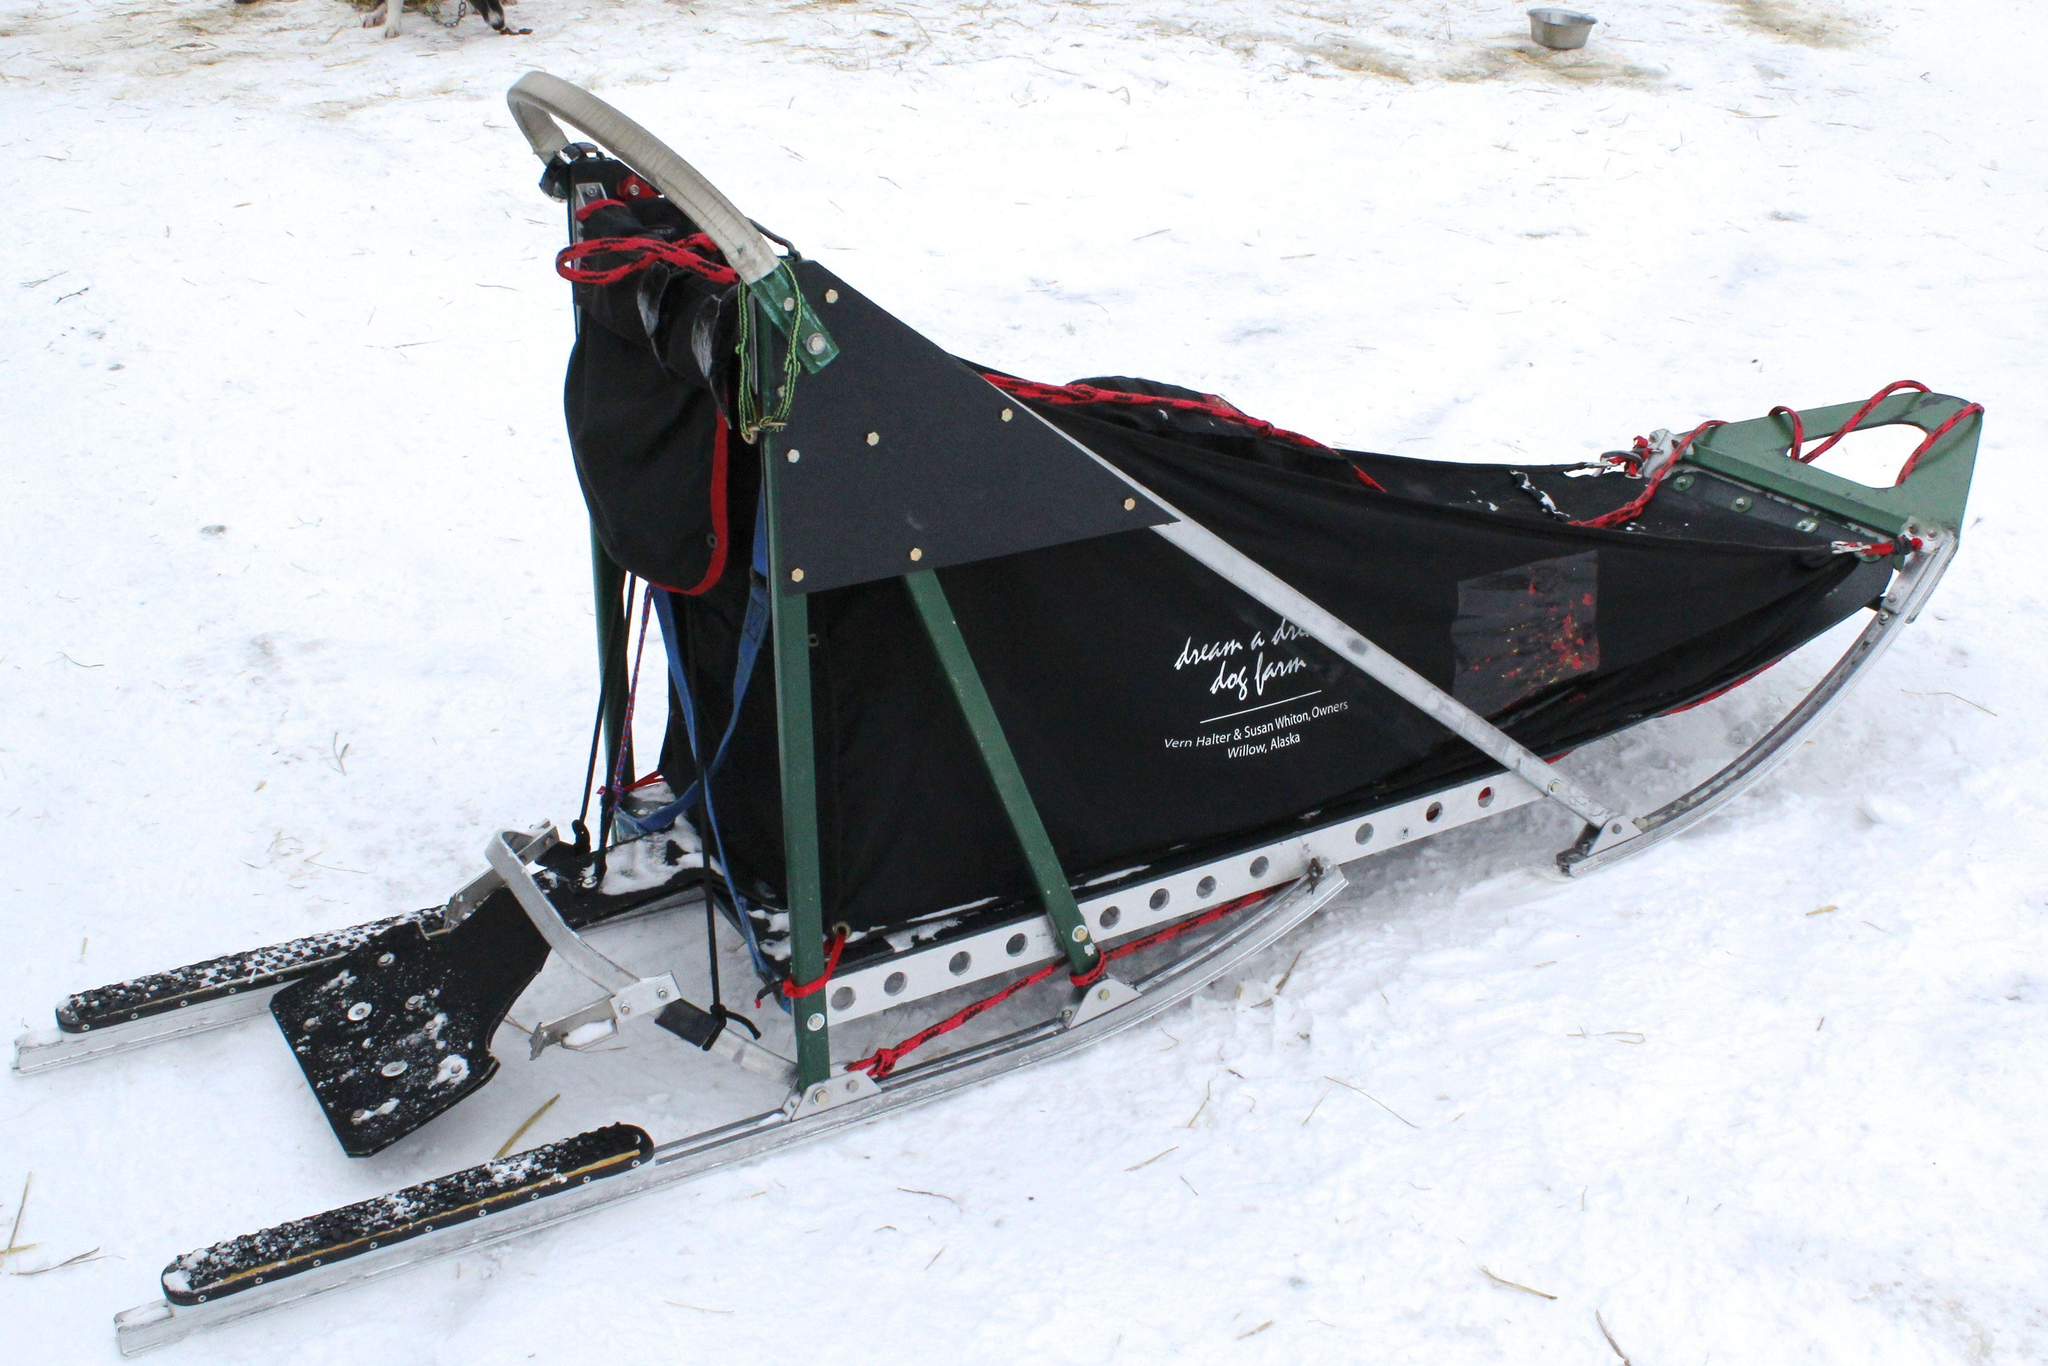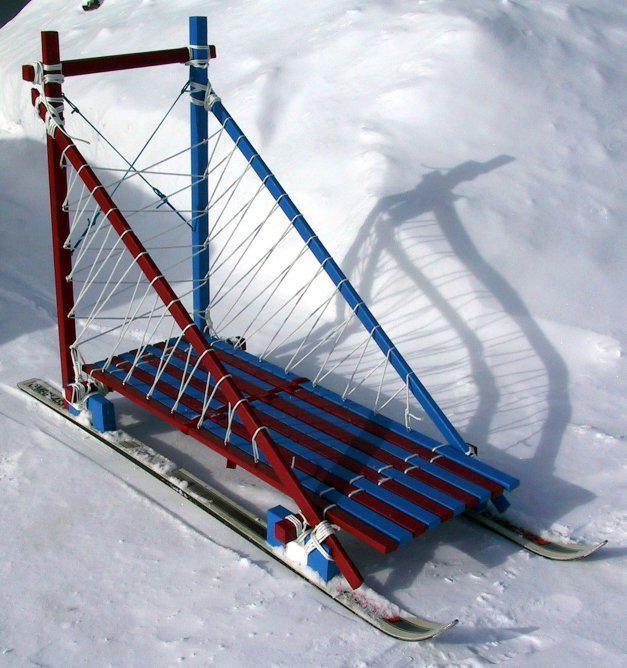The first image is the image on the left, the second image is the image on the right. Given the left and right images, does the statement "The left image contains an empty, uncovered wood-framed sled with a straight bar for a handle, netting on the sides and a black base, and the right image contains a sled with a nylon cover and curved handle." hold true? Answer yes or no. No. The first image is the image on the left, the second image is the image on the right. Given the left and right images, does the statement "There is exactly one sled in every photo, with one being made of wood with open design and black bottom and the other made with a tent material that is closed." hold true? Answer yes or no. No. 